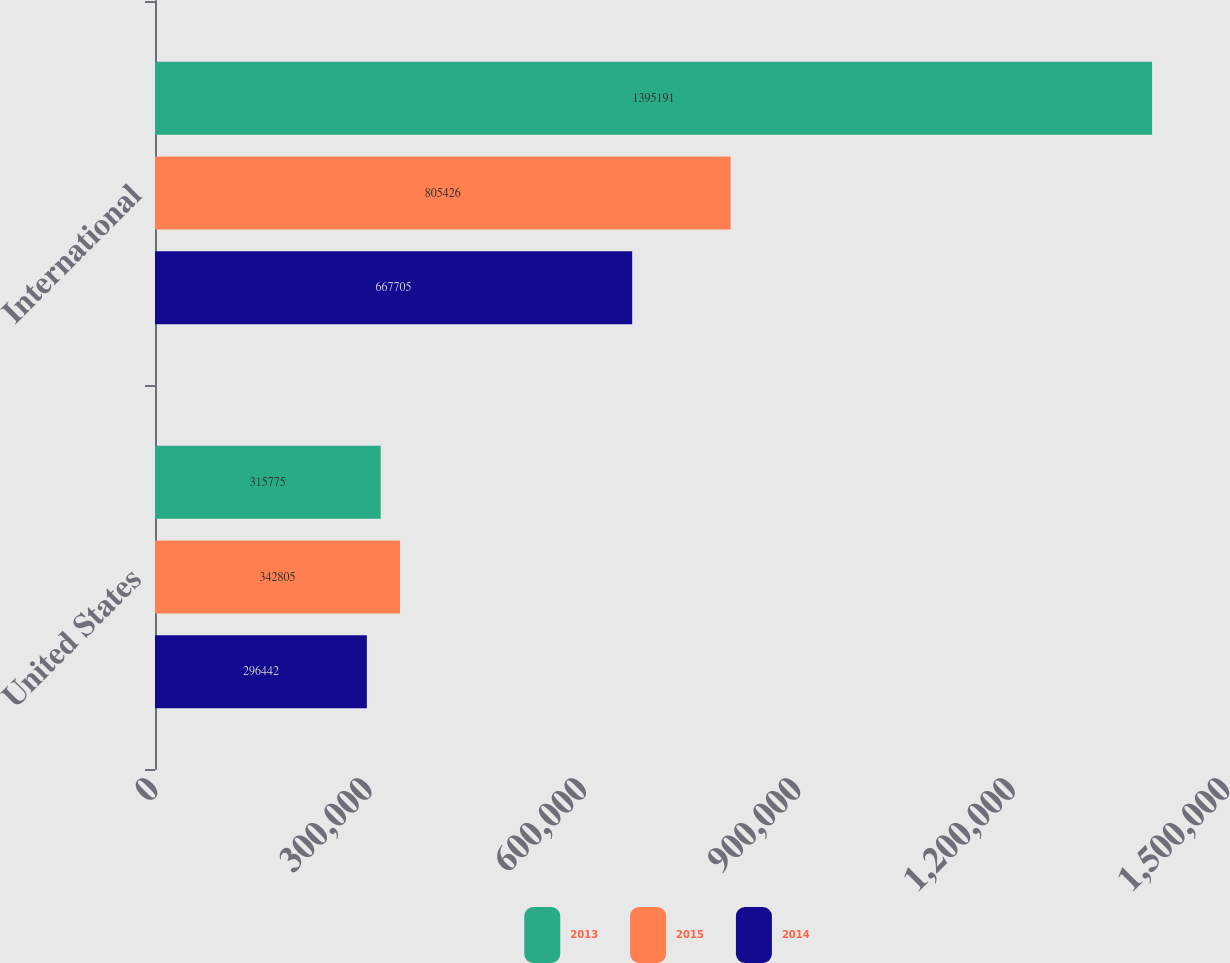Convert chart to OTSL. <chart><loc_0><loc_0><loc_500><loc_500><stacked_bar_chart><ecel><fcel>United States<fcel>International<nl><fcel>2013<fcel>315775<fcel>1.39519e+06<nl><fcel>2015<fcel>342805<fcel>805426<nl><fcel>2014<fcel>296442<fcel>667705<nl></chart> 